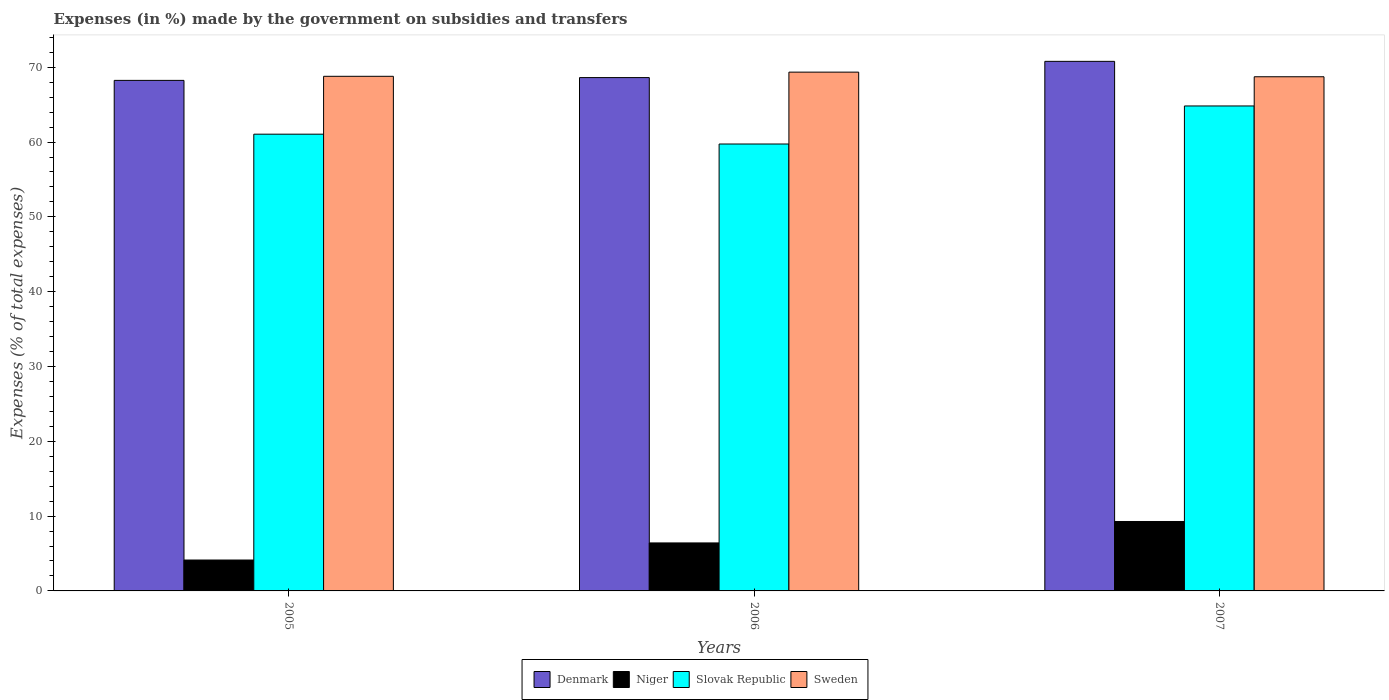How many different coloured bars are there?
Offer a terse response. 4. Are the number of bars per tick equal to the number of legend labels?
Offer a very short reply. Yes. How many bars are there on the 2nd tick from the left?
Make the answer very short. 4. What is the label of the 3rd group of bars from the left?
Your answer should be very brief. 2007. What is the percentage of expenses made by the government on subsidies and transfers in Niger in 2006?
Your response must be concise. 6.42. Across all years, what is the maximum percentage of expenses made by the government on subsidies and transfers in Niger?
Make the answer very short. 9.28. Across all years, what is the minimum percentage of expenses made by the government on subsidies and transfers in Denmark?
Your answer should be compact. 68.24. In which year was the percentage of expenses made by the government on subsidies and transfers in Sweden maximum?
Keep it short and to the point. 2006. What is the total percentage of expenses made by the government on subsidies and transfers in Denmark in the graph?
Your answer should be very brief. 207.64. What is the difference between the percentage of expenses made by the government on subsidies and transfers in Niger in 2005 and that in 2006?
Provide a short and direct response. -2.29. What is the difference between the percentage of expenses made by the government on subsidies and transfers in Sweden in 2007 and the percentage of expenses made by the government on subsidies and transfers in Denmark in 2006?
Ensure brevity in your answer.  0.11. What is the average percentage of expenses made by the government on subsidies and transfers in Niger per year?
Provide a succinct answer. 6.61. In the year 2007, what is the difference between the percentage of expenses made by the government on subsidies and transfers in Sweden and percentage of expenses made by the government on subsidies and transfers in Denmark?
Keep it short and to the point. -2.06. What is the ratio of the percentage of expenses made by the government on subsidies and transfers in Slovak Republic in 2006 to that in 2007?
Your answer should be compact. 0.92. What is the difference between the highest and the second highest percentage of expenses made by the government on subsidies and transfers in Niger?
Your answer should be compact. 2.86. What is the difference between the highest and the lowest percentage of expenses made by the government on subsidies and transfers in Slovak Republic?
Provide a short and direct response. 5.09. Is the sum of the percentage of expenses made by the government on subsidies and transfers in Denmark in 2005 and 2006 greater than the maximum percentage of expenses made by the government on subsidies and transfers in Sweden across all years?
Ensure brevity in your answer.  Yes. Is it the case that in every year, the sum of the percentage of expenses made by the government on subsidies and transfers in Denmark and percentage of expenses made by the government on subsidies and transfers in Sweden is greater than the sum of percentage of expenses made by the government on subsidies and transfers in Niger and percentage of expenses made by the government on subsidies and transfers in Slovak Republic?
Offer a terse response. Yes. What does the 2nd bar from the left in 2006 represents?
Give a very brief answer. Niger. Is it the case that in every year, the sum of the percentage of expenses made by the government on subsidies and transfers in Sweden and percentage of expenses made by the government on subsidies and transfers in Niger is greater than the percentage of expenses made by the government on subsidies and transfers in Denmark?
Offer a very short reply. Yes. How many years are there in the graph?
Ensure brevity in your answer.  3. Are the values on the major ticks of Y-axis written in scientific E-notation?
Provide a short and direct response. No. Does the graph contain grids?
Provide a succinct answer. No. Where does the legend appear in the graph?
Your answer should be compact. Bottom center. How many legend labels are there?
Provide a short and direct response. 4. What is the title of the graph?
Offer a terse response. Expenses (in %) made by the government on subsidies and transfers. What is the label or title of the X-axis?
Make the answer very short. Years. What is the label or title of the Y-axis?
Make the answer very short. Expenses (% of total expenses). What is the Expenses (% of total expenses) in Denmark in 2005?
Provide a succinct answer. 68.24. What is the Expenses (% of total expenses) in Niger in 2005?
Provide a short and direct response. 4.13. What is the Expenses (% of total expenses) in Slovak Republic in 2005?
Make the answer very short. 61.05. What is the Expenses (% of total expenses) of Sweden in 2005?
Provide a succinct answer. 68.79. What is the Expenses (% of total expenses) of Denmark in 2006?
Provide a short and direct response. 68.62. What is the Expenses (% of total expenses) in Niger in 2006?
Provide a succinct answer. 6.42. What is the Expenses (% of total expenses) of Slovak Republic in 2006?
Keep it short and to the point. 59.74. What is the Expenses (% of total expenses) in Sweden in 2006?
Your response must be concise. 69.34. What is the Expenses (% of total expenses) in Denmark in 2007?
Your response must be concise. 70.79. What is the Expenses (% of total expenses) in Niger in 2007?
Offer a terse response. 9.28. What is the Expenses (% of total expenses) in Slovak Republic in 2007?
Give a very brief answer. 64.82. What is the Expenses (% of total expenses) in Sweden in 2007?
Keep it short and to the point. 68.73. Across all years, what is the maximum Expenses (% of total expenses) of Denmark?
Your response must be concise. 70.79. Across all years, what is the maximum Expenses (% of total expenses) in Niger?
Offer a terse response. 9.28. Across all years, what is the maximum Expenses (% of total expenses) of Slovak Republic?
Make the answer very short. 64.82. Across all years, what is the maximum Expenses (% of total expenses) of Sweden?
Your answer should be very brief. 69.34. Across all years, what is the minimum Expenses (% of total expenses) in Denmark?
Make the answer very short. 68.24. Across all years, what is the minimum Expenses (% of total expenses) in Niger?
Keep it short and to the point. 4.13. Across all years, what is the minimum Expenses (% of total expenses) of Slovak Republic?
Offer a very short reply. 59.74. Across all years, what is the minimum Expenses (% of total expenses) in Sweden?
Give a very brief answer. 68.73. What is the total Expenses (% of total expenses) in Denmark in the graph?
Keep it short and to the point. 207.64. What is the total Expenses (% of total expenses) of Niger in the graph?
Your answer should be very brief. 19.82. What is the total Expenses (% of total expenses) of Slovak Republic in the graph?
Make the answer very short. 185.61. What is the total Expenses (% of total expenses) in Sweden in the graph?
Give a very brief answer. 206.86. What is the difference between the Expenses (% of total expenses) of Denmark in 2005 and that in 2006?
Make the answer very short. -0.37. What is the difference between the Expenses (% of total expenses) of Niger in 2005 and that in 2006?
Provide a short and direct response. -2.29. What is the difference between the Expenses (% of total expenses) of Slovak Republic in 2005 and that in 2006?
Provide a short and direct response. 1.31. What is the difference between the Expenses (% of total expenses) in Sweden in 2005 and that in 2006?
Offer a very short reply. -0.56. What is the difference between the Expenses (% of total expenses) of Denmark in 2005 and that in 2007?
Provide a short and direct response. -2.54. What is the difference between the Expenses (% of total expenses) of Niger in 2005 and that in 2007?
Your answer should be compact. -5.15. What is the difference between the Expenses (% of total expenses) in Slovak Republic in 2005 and that in 2007?
Keep it short and to the point. -3.77. What is the difference between the Expenses (% of total expenses) of Sweden in 2005 and that in 2007?
Offer a very short reply. 0.06. What is the difference between the Expenses (% of total expenses) of Denmark in 2006 and that in 2007?
Your answer should be compact. -2.17. What is the difference between the Expenses (% of total expenses) in Niger in 2006 and that in 2007?
Provide a succinct answer. -2.86. What is the difference between the Expenses (% of total expenses) in Slovak Republic in 2006 and that in 2007?
Provide a succinct answer. -5.09. What is the difference between the Expenses (% of total expenses) of Sweden in 2006 and that in 2007?
Ensure brevity in your answer.  0.62. What is the difference between the Expenses (% of total expenses) in Denmark in 2005 and the Expenses (% of total expenses) in Niger in 2006?
Provide a short and direct response. 61.83. What is the difference between the Expenses (% of total expenses) in Denmark in 2005 and the Expenses (% of total expenses) in Slovak Republic in 2006?
Your response must be concise. 8.5. What is the difference between the Expenses (% of total expenses) of Denmark in 2005 and the Expenses (% of total expenses) of Sweden in 2006?
Offer a terse response. -1.1. What is the difference between the Expenses (% of total expenses) in Niger in 2005 and the Expenses (% of total expenses) in Slovak Republic in 2006?
Provide a succinct answer. -55.61. What is the difference between the Expenses (% of total expenses) in Niger in 2005 and the Expenses (% of total expenses) in Sweden in 2006?
Give a very brief answer. -65.21. What is the difference between the Expenses (% of total expenses) of Slovak Republic in 2005 and the Expenses (% of total expenses) of Sweden in 2006?
Your answer should be very brief. -8.29. What is the difference between the Expenses (% of total expenses) of Denmark in 2005 and the Expenses (% of total expenses) of Niger in 2007?
Give a very brief answer. 58.96. What is the difference between the Expenses (% of total expenses) in Denmark in 2005 and the Expenses (% of total expenses) in Slovak Republic in 2007?
Offer a very short reply. 3.42. What is the difference between the Expenses (% of total expenses) in Denmark in 2005 and the Expenses (% of total expenses) in Sweden in 2007?
Ensure brevity in your answer.  -0.49. What is the difference between the Expenses (% of total expenses) in Niger in 2005 and the Expenses (% of total expenses) in Slovak Republic in 2007?
Offer a very short reply. -60.69. What is the difference between the Expenses (% of total expenses) in Niger in 2005 and the Expenses (% of total expenses) in Sweden in 2007?
Your response must be concise. -64.6. What is the difference between the Expenses (% of total expenses) in Slovak Republic in 2005 and the Expenses (% of total expenses) in Sweden in 2007?
Make the answer very short. -7.68. What is the difference between the Expenses (% of total expenses) in Denmark in 2006 and the Expenses (% of total expenses) in Niger in 2007?
Ensure brevity in your answer.  59.34. What is the difference between the Expenses (% of total expenses) in Denmark in 2006 and the Expenses (% of total expenses) in Slovak Republic in 2007?
Your answer should be very brief. 3.79. What is the difference between the Expenses (% of total expenses) in Denmark in 2006 and the Expenses (% of total expenses) in Sweden in 2007?
Provide a short and direct response. -0.11. What is the difference between the Expenses (% of total expenses) of Niger in 2006 and the Expenses (% of total expenses) of Slovak Republic in 2007?
Make the answer very short. -58.41. What is the difference between the Expenses (% of total expenses) of Niger in 2006 and the Expenses (% of total expenses) of Sweden in 2007?
Make the answer very short. -62.31. What is the difference between the Expenses (% of total expenses) of Slovak Republic in 2006 and the Expenses (% of total expenses) of Sweden in 2007?
Give a very brief answer. -8.99. What is the average Expenses (% of total expenses) of Denmark per year?
Offer a very short reply. 69.21. What is the average Expenses (% of total expenses) of Niger per year?
Make the answer very short. 6.61. What is the average Expenses (% of total expenses) of Slovak Republic per year?
Keep it short and to the point. 61.87. What is the average Expenses (% of total expenses) of Sweden per year?
Offer a very short reply. 68.95. In the year 2005, what is the difference between the Expenses (% of total expenses) in Denmark and Expenses (% of total expenses) in Niger?
Your response must be concise. 64.11. In the year 2005, what is the difference between the Expenses (% of total expenses) in Denmark and Expenses (% of total expenses) in Slovak Republic?
Make the answer very short. 7.19. In the year 2005, what is the difference between the Expenses (% of total expenses) in Denmark and Expenses (% of total expenses) in Sweden?
Offer a terse response. -0.54. In the year 2005, what is the difference between the Expenses (% of total expenses) in Niger and Expenses (% of total expenses) in Slovak Republic?
Your response must be concise. -56.92. In the year 2005, what is the difference between the Expenses (% of total expenses) of Niger and Expenses (% of total expenses) of Sweden?
Give a very brief answer. -64.66. In the year 2005, what is the difference between the Expenses (% of total expenses) in Slovak Republic and Expenses (% of total expenses) in Sweden?
Make the answer very short. -7.74. In the year 2006, what is the difference between the Expenses (% of total expenses) in Denmark and Expenses (% of total expenses) in Niger?
Your answer should be very brief. 62.2. In the year 2006, what is the difference between the Expenses (% of total expenses) in Denmark and Expenses (% of total expenses) in Slovak Republic?
Give a very brief answer. 8.88. In the year 2006, what is the difference between the Expenses (% of total expenses) in Denmark and Expenses (% of total expenses) in Sweden?
Your answer should be compact. -0.73. In the year 2006, what is the difference between the Expenses (% of total expenses) of Niger and Expenses (% of total expenses) of Slovak Republic?
Your response must be concise. -53.32. In the year 2006, what is the difference between the Expenses (% of total expenses) of Niger and Expenses (% of total expenses) of Sweden?
Offer a very short reply. -62.93. In the year 2006, what is the difference between the Expenses (% of total expenses) of Slovak Republic and Expenses (% of total expenses) of Sweden?
Offer a terse response. -9.61. In the year 2007, what is the difference between the Expenses (% of total expenses) of Denmark and Expenses (% of total expenses) of Niger?
Keep it short and to the point. 61.51. In the year 2007, what is the difference between the Expenses (% of total expenses) in Denmark and Expenses (% of total expenses) in Slovak Republic?
Make the answer very short. 5.96. In the year 2007, what is the difference between the Expenses (% of total expenses) in Denmark and Expenses (% of total expenses) in Sweden?
Provide a short and direct response. 2.06. In the year 2007, what is the difference between the Expenses (% of total expenses) of Niger and Expenses (% of total expenses) of Slovak Republic?
Offer a very short reply. -55.54. In the year 2007, what is the difference between the Expenses (% of total expenses) of Niger and Expenses (% of total expenses) of Sweden?
Provide a short and direct response. -59.45. In the year 2007, what is the difference between the Expenses (% of total expenses) of Slovak Republic and Expenses (% of total expenses) of Sweden?
Give a very brief answer. -3.9. What is the ratio of the Expenses (% of total expenses) in Denmark in 2005 to that in 2006?
Make the answer very short. 0.99. What is the ratio of the Expenses (% of total expenses) of Niger in 2005 to that in 2006?
Give a very brief answer. 0.64. What is the ratio of the Expenses (% of total expenses) of Slovak Republic in 2005 to that in 2006?
Your answer should be compact. 1.02. What is the ratio of the Expenses (% of total expenses) in Denmark in 2005 to that in 2007?
Keep it short and to the point. 0.96. What is the ratio of the Expenses (% of total expenses) of Niger in 2005 to that in 2007?
Provide a short and direct response. 0.45. What is the ratio of the Expenses (% of total expenses) of Slovak Republic in 2005 to that in 2007?
Your response must be concise. 0.94. What is the ratio of the Expenses (% of total expenses) of Sweden in 2005 to that in 2007?
Give a very brief answer. 1. What is the ratio of the Expenses (% of total expenses) in Denmark in 2006 to that in 2007?
Offer a very short reply. 0.97. What is the ratio of the Expenses (% of total expenses) in Niger in 2006 to that in 2007?
Ensure brevity in your answer.  0.69. What is the ratio of the Expenses (% of total expenses) in Slovak Republic in 2006 to that in 2007?
Keep it short and to the point. 0.92. What is the difference between the highest and the second highest Expenses (% of total expenses) in Denmark?
Your response must be concise. 2.17. What is the difference between the highest and the second highest Expenses (% of total expenses) of Niger?
Ensure brevity in your answer.  2.86. What is the difference between the highest and the second highest Expenses (% of total expenses) of Slovak Republic?
Offer a terse response. 3.77. What is the difference between the highest and the second highest Expenses (% of total expenses) in Sweden?
Ensure brevity in your answer.  0.56. What is the difference between the highest and the lowest Expenses (% of total expenses) in Denmark?
Provide a succinct answer. 2.54. What is the difference between the highest and the lowest Expenses (% of total expenses) in Niger?
Your answer should be compact. 5.15. What is the difference between the highest and the lowest Expenses (% of total expenses) in Slovak Republic?
Make the answer very short. 5.09. What is the difference between the highest and the lowest Expenses (% of total expenses) in Sweden?
Your answer should be compact. 0.62. 